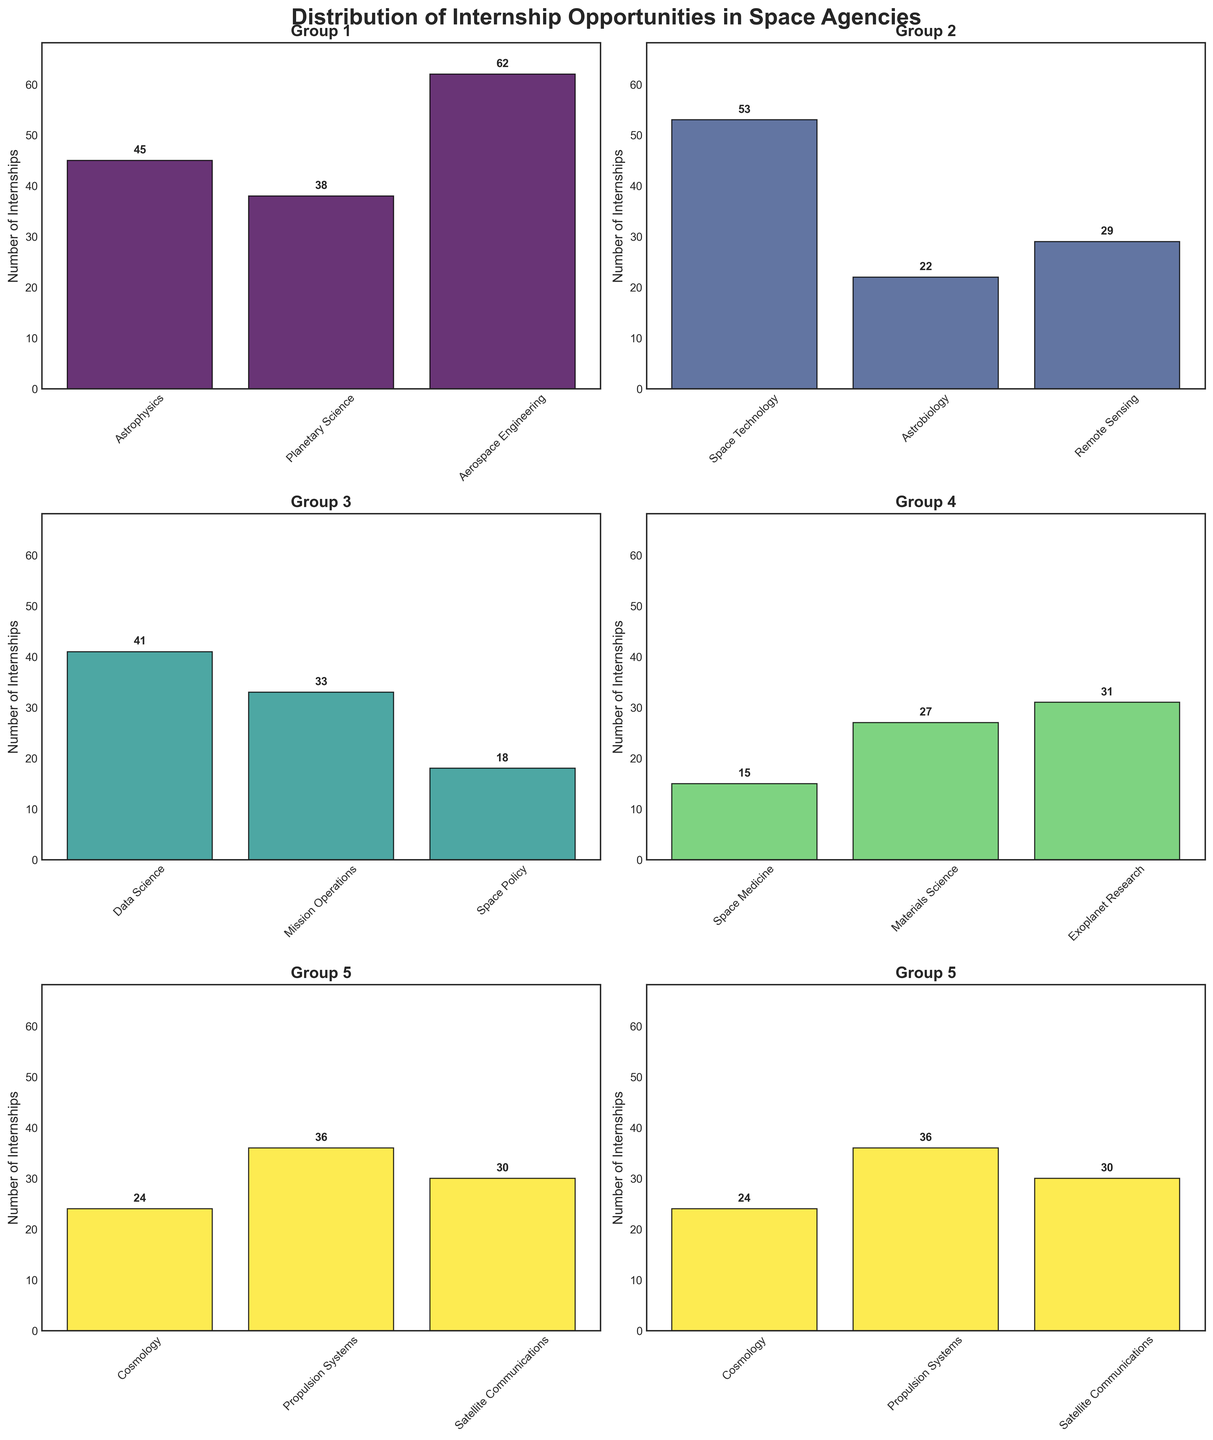How many groups are presented in the figure? The figure shows six subplots, five of which contain three data points each, and the last subplot contains the remaining three data points, resulting in five groups overall.
Answer: 5 What is the title of the figure? The title of the figure is displayed prominently at the top, describing the subject of the visualization. It reads "Distribution of Internship Opportunities in Space Agencies".
Answer: Distribution of Internship Opportunities in Space Agencies Which group has the most number of internships for Astrobiology? Only one group contains the data point for Astrobiology, where it shows the number of internships for that field. The group that has Astrobiology shows 22 internships.
Answer: Group 3 What's the average number of internships for the fields in Group 2? Group 2 contains data points for the fields Space Technology (53), Astrobiology (22), and Remote Sensing (29). The average is calculated as (53 + 22 + 29) / 3 = 104 / 3 ≈ 34.67.
Answer: 34.67 Which field has the third highest number of internships in Group 5? Group 5 has data points for the fields Cosmology (24), Propulsion Systems (36), and Satellite Communications (30). The third highest number of internships is 24 for Cosmology.
Answer: Cosmology How do the number of internships for Space Medicine compare to Space Policy? Both fields are located in the same group, with the number of internships for Space Medicine being 15 and the number for Space Policy being 18. Hence, Space Medicine has fewer internships than Space Policy.
Answer: Space Medicine has fewer What’s the total number of internships in Group 1? Group 1 contains data points for Astrophysics (45), Planetary Science (38), and Aerospace Engineering (62). The total number of internships is 45 + 38 + 62 = 145.
Answer: 145 Which field in Group 4 has the highest number of internships? Group 4 contains the fields Data Science (41), Mission Operations (33), and Space Policy (18). Among these, Data Science has the highest number of internships at 41.
Answer: Data Science By how much do the internships in Aerospace Engineering exceed those in Astrobiology? The number of internships for Aerospace Engineering is in Group 1 (62), and the number for Astrobiology is in Group 2 (22). The difference is 62 - 22 = 40 more internships for Aerospace Engineering.
Answer: 40 